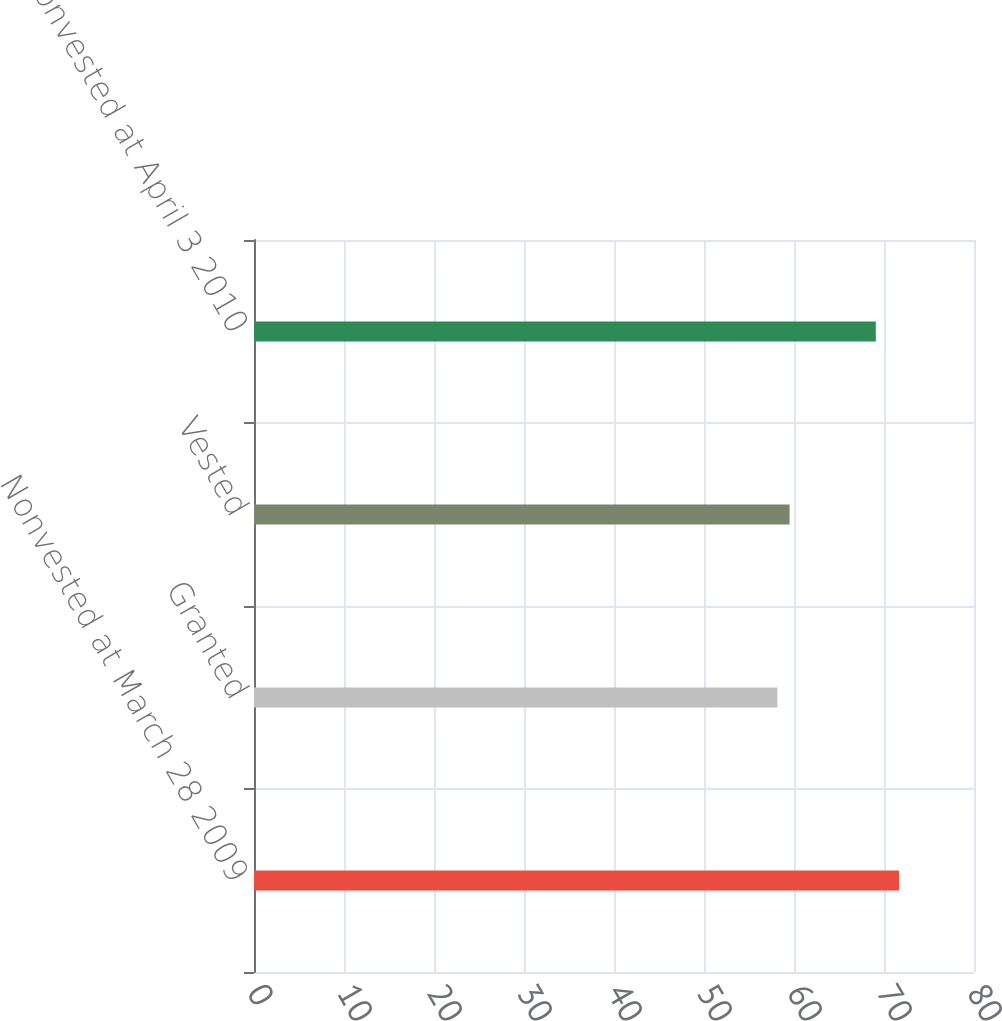Convert chart. <chart><loc_0><loc_0><loc_500><loc_500><bar_chart><fcel>Nonvested at March 28 2009<fcel>Granted<fcel>Vested<fcel>Nonvested at April 3 2010<nl><fcel>71.67<fcel>58.16<fcel>59.51<fcel>69.09<nl></chart> 